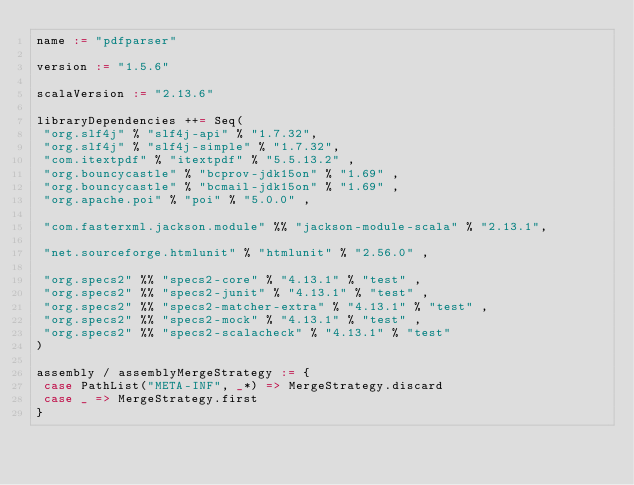<code> <loc_0><loc_0><loc_500><loc_500><_Scala_>name := "pdfparser"

version := "1.5.6"

scalaVersion := "2.13.6"

libraryDependencies ++= Seq(
 "org.slf4j" % "slf4j-api" % "1.7.32",
 "org.slf4j" % "slf4j-simple" % "1.7.32",
 "com.itextpdf" % "itextpdf" % "5.5.13.2" ,
 "org.bouncycastle" % "bcprov-jdk15on" % "1.69" ,
 "org.bouncycastle" % "bcmail-jdk15on" % "1.69" ,
 "org.apache.poi" % "poi" % "5.0.0" ,

 "com.fasterxml.jackson.module" %% "jackson-module-scala" % "2.13.1",

 "net.sourceforge.htmlunit" % "htmlunit" % "2.56.0" ,

 "org.specs2" %% "specs2-core" % "4.13.1" % "test" ,
 "org.specs2" %% "specs2-junit" % "4.13.1" % "test" ,
 "org.specs2" %% "specs2-matcher-extra" % "4.13.1" % "test" ,
 "org.specs2" %% "specs2-mock" % "4.13.1" % "test" ,
 "org.specs2" %% "specs2-scalacheck" % "4.13.1" % "test"
)

assembly / assemblyMergeStrategy := {
 case PathList("META-INF", _*) => MergeStrategy.discard
 case _ => MergeStrategy.first
}
</code> 